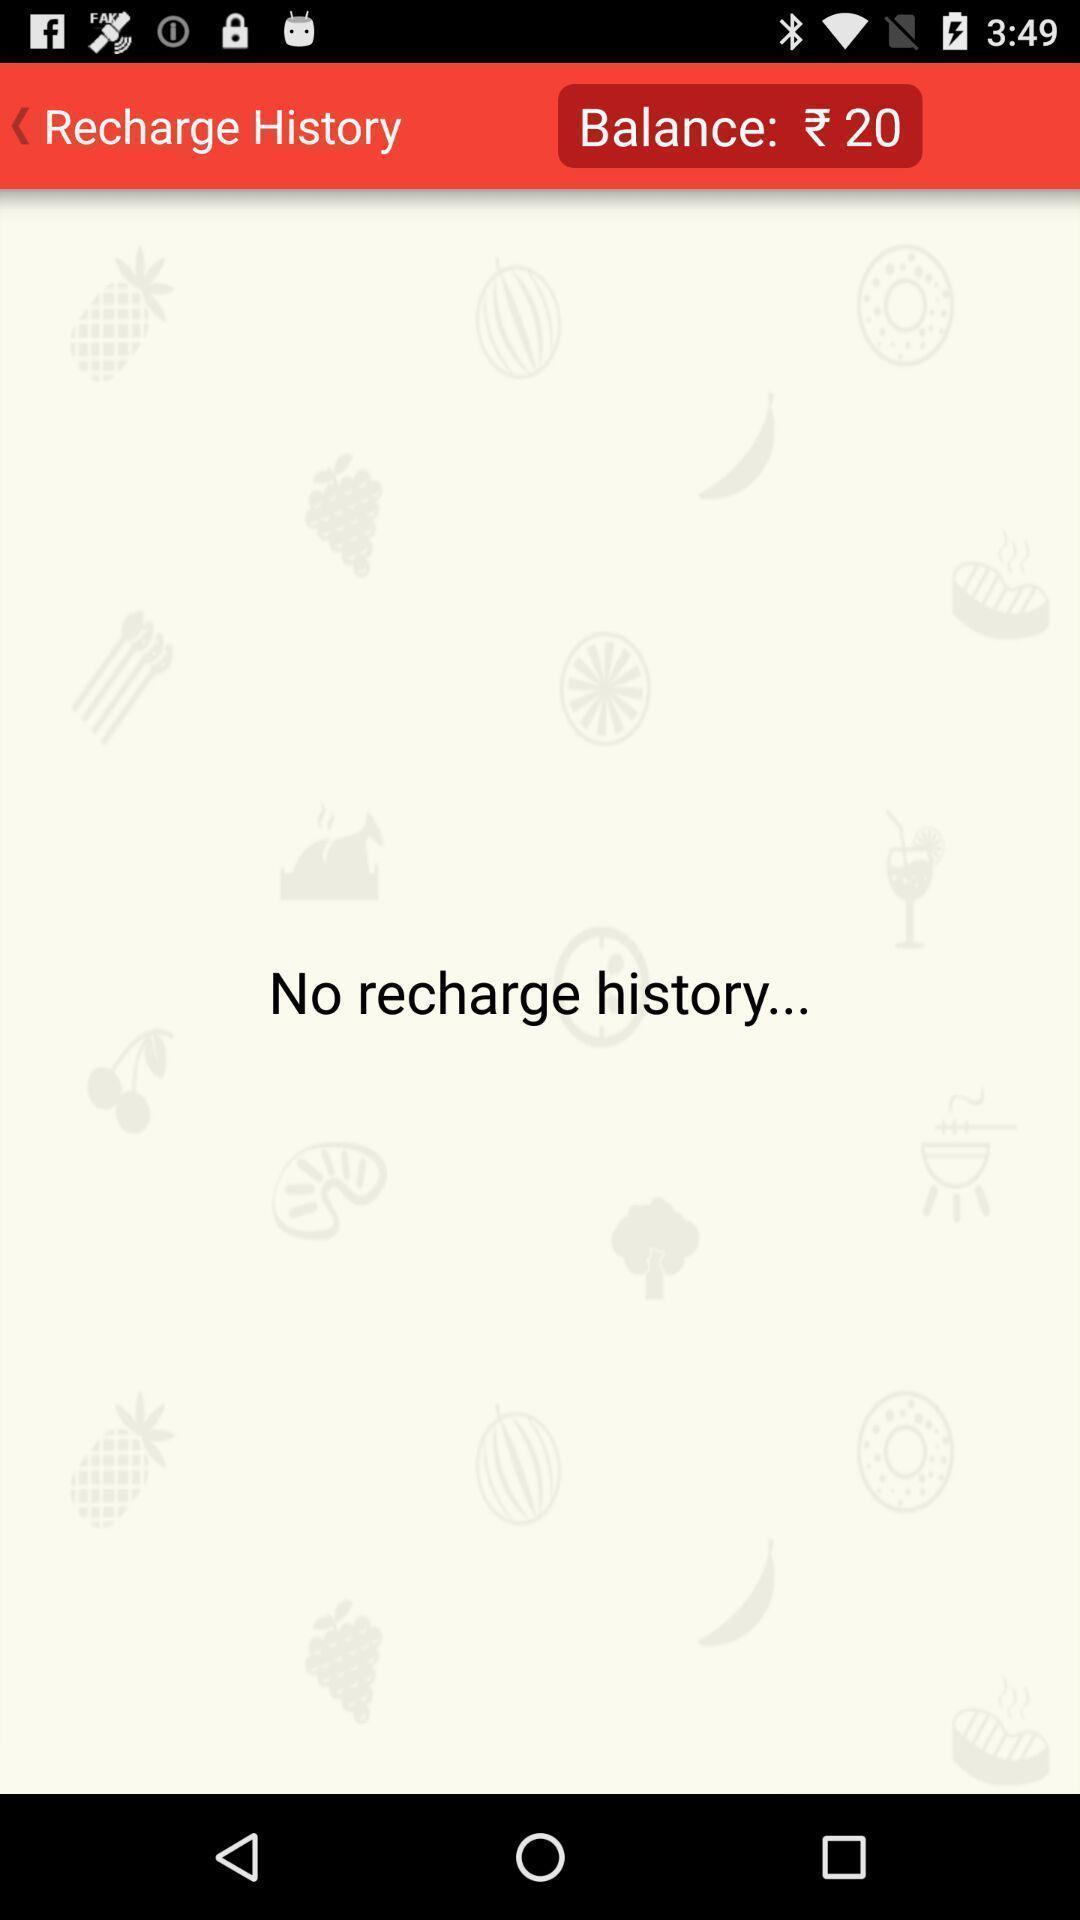Give me a summary of this screen capture. Photo showing recharge history and balance. 